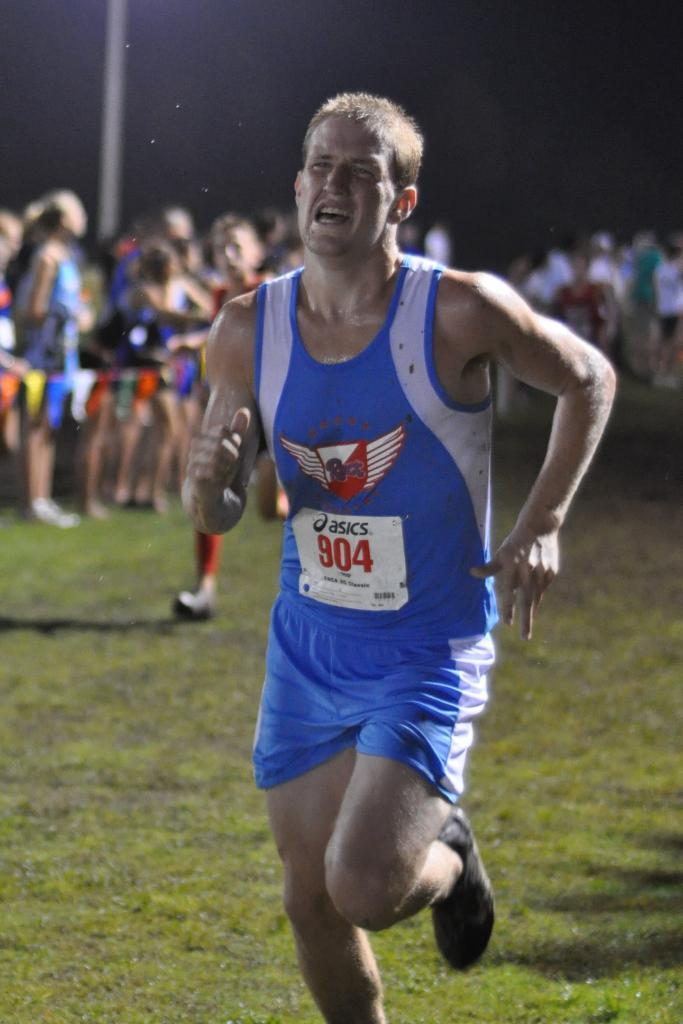<image>
Provide a brief description of the given image. A runner wearing  number 804 is really struggling in a foot race. 